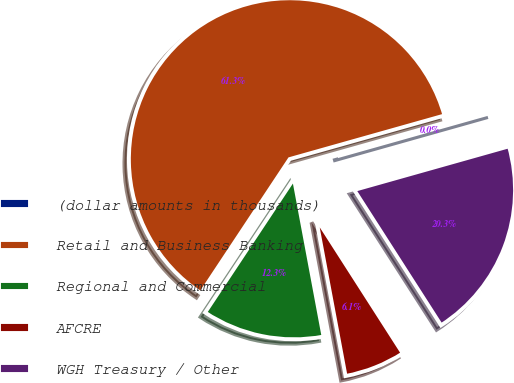Convert chart to OTSL. <chart><loc_0><loc_0><loc_500><loc_500><pie_chart><fcel>(dollar amounts in thousands)<fcel>Retail and Business Banking<fcel>Regional and Commercial<fcel>AFCRE<fcel>WGH Treasury / Other<nl><fcel>0.0%<fcel>61.3%<fcel>12.26%<fcel>6.13%<fcel>20.29%<nl></chart> 